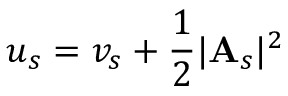Convert formula to latex. <formula><loc_0><loc_0><loc_500><loc_500>u _ { s } = v _ { s } + \frac { 1 } { 2 } | A _ { s } | ^ { 2 }</formula> 